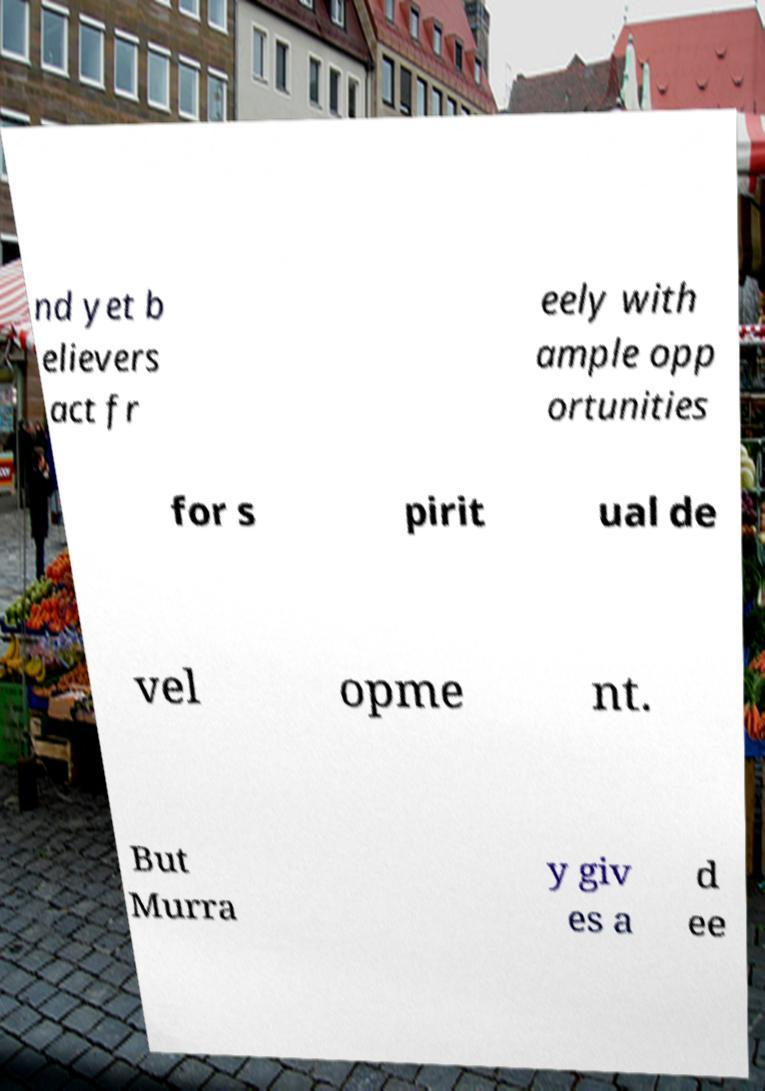I need the written content from this picture converted into text. Can you do that? nd yet b elievers act fr eely with ample opp ortunities for s pirit ual de vel opme nt. But Murra y giv es a d ee 